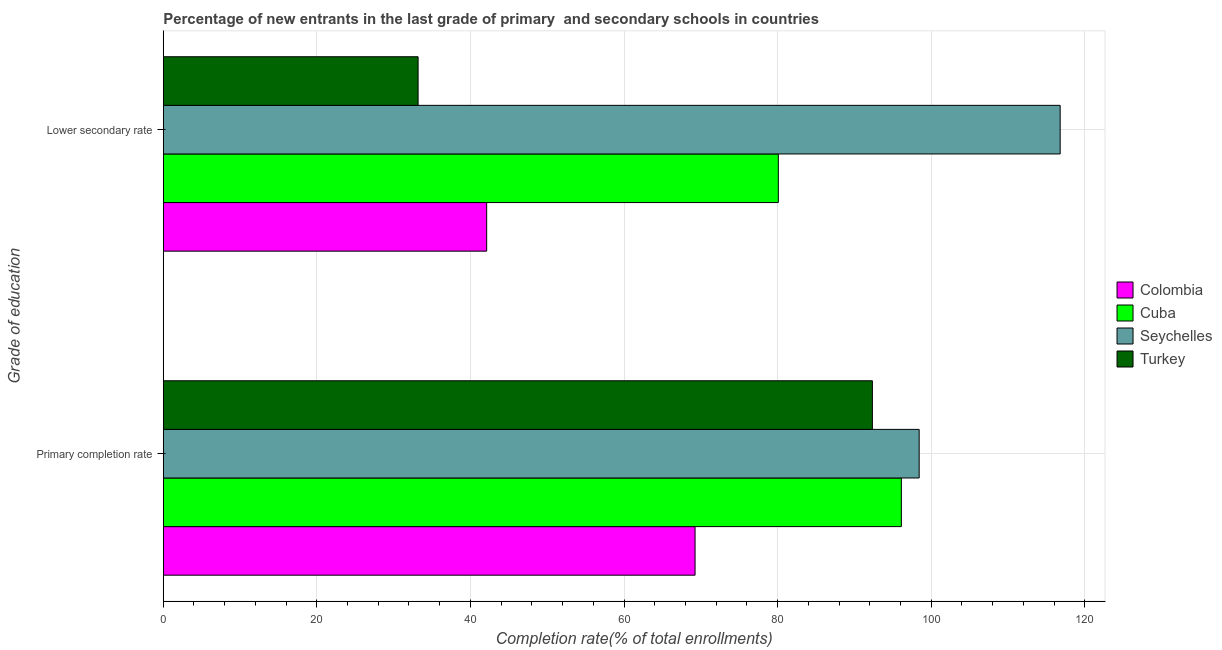How many different coloured bars are there?
Make the answer very short. 4. How many groups of bars are there?
Ensure brevity in your answer.  2. Are the number of bars on each tick of the Y-axis equal?
Ensure brevity in your answer.  Yes. How many bars are there on the 1st tick from the top?
Provide a short and direct response. 4. What is the label of the 2nd group of bars from the top?
Offer a terse response. Primary completion rate. What is the completion rate in primary schools in Cuba?
Offer a terse response. 96.12. Across all countries, what is the maximum completion rate in secondary schools?
Ensure brevity in your answer.  116.8. Across all countries, what is the minimum completion rate in secondary schools?
Make the answer very short. 33.19. In which country was the completion rate in secondary schools maximum?
Ensure brevity in your answer.  Seychelles. What is the total completion rate in secondary schools in the graph?
Your answer should be very brief. 272.2. What is the difference between the completion rate in secondary schools in Colombia and that in Cuba?
Make the answer very short. -37.98. What is the difference between the completion rate in primary schools in Colombia and the completion rate in secondary schools in Cuba?
Your answer should be very brief. -10.84. What is the average completion rate in secondary schools per country?
Keep it short and to the point. 68.05. What is the difference between the completion rate in secondary schools and completion rate in primary schools in Colombia?
Your answer should be compact. -27.14. In how many countries, is the completion rate in primary schools greater than 16 %?
Provide a short and direct response. 4. What is the ratio of the completion rate in secondary schools in Seychelles to that in Colombia?
Ensure brevity in your answer.  2.77. Is the completion rate in secondary schools in Cuba less than that in Turkey?
Ensure brevity in your answer.  No. What does the 2nd bar from the top in Primary completion rate represents?
Offer a very short reply. Seychelles. What does the 4th bar from the bottom in Primary completion rate represents?
Offer a terse response. Turkey. How many bars are there?
Keep it short and to the point. 8. How many countries are there in the graph?
Your answer should be compact. 4. How many legend labels are there?
Provide a short and direct response. 4. How are the legend labels stacked?
Offer a terse response. Vertical. What is the title of the graph?
Offer a very short reply. Percentage of new entrants in the last grade of primary  and secondary schools in countries. What is the label or title of the X-axis?
Make the answer very short. Completion rate(% of total enrollments). What is the label or title of the Y-axis?
Offer a terse response. Grade of education. What is the Completion rate(% of total enrollments) in Colombia in Primary completion rate?
Make the answer very short. 69.25. What is the Completion rate(% of total enrollments) of Cuba in Primary completion rate?
Offer a terse response. 96.12. What is the Completion rate(% of total enrollments) of Seychelles in Primary completion rate?
Offer a very short reply. 98.44. What is the Completion rate(% of total enrollments) of Turkey in Primary completion rate?
Provide a short and direct response. 92.35. What is the Completion rate(% of total enrollments) in Colombia in Lower secondary rate?
Offer a very short reply. 42.12. What is the Completion rate(% of total enrollments) in Cuba in Lower secondary rate?
Keep it short and to the point. 80.1. What is the Completion rate(% of total enrollments) in Seychelles in Lower secondary rate?
Provide a succinct answer. 116.8. What is the Completion rate(% of total enrollments) of Turkey in Lower secondary rate?
Offer a very short reply. 33.19. Across all Grade of education, what is the maximum Completion rate(% of total enrollments) in Colombia?
Your response must be concise. 69.25. Across all Grade of education, what is the maximum Completion rate(% of total enrollments) of Cuba?
Ensure brevity in your answer.  96.12. Across all Grade of education, what is the maximum Completion rate(% of total enrollments) in Seychelles?
Provide a succinct answer. 116.8. Across all Grade of education, what is the maximum Completion rate(% of total enrollments) of Turkey?
Provide a short and direct response. 92.35. Across all Grade of education, what is the minimum Completion rate(% of total enrollments) in Colombia?
Your response must be concise. 42.12. Across all Grade of education, what is the minimum Completion rate(% of total enrollments) of Cuba?
Offer a terse response. 80.1. Across all Grade of education, what is the minimum Completion rate(% of total enrollments) of Seychelles?
Your answer should be very brief. 98.44. Across all Grade of education, what is the minimum Completion rate(% of total enrollments) of Turkey?
Give a very brief answer. 33.19. What is the total Completion rate(% of total enrollments) of Colombia in the graph?
Ensure brevity in your answer.  111.37. What is the total Completion rate(% of total enrollments) of Cuba in the graph?
Offer a very short reply. 176.22. What is the total Completion rate(% of total enrollments) in Seychelles in the graph?
Your answer should be very brief. 215.24. What is the total Completion rate(% of total enrollments) of Turkey in the graph?
Ensure brevity in your answer.  125.53. What is the difference between the Completion rate(% of total enrollments) of Colombia in Primary completion rate and that in Lower secondary rate?
Your response must be concise. 27.14. What is the difference between the Completion rate(% of total enrollments) of Cuba in Primary completion rate and that in Lower secondary rate?
Give a very brief answer. 16.02. What is the difference between the Completion rate(% of total enrollments) of Seychelles in Primary completion rate and that in Lower secondary rate?
Make the answer very short. -18.36. What is the difference between the Completion rate(% of total enrollments) in Turkey in Primary completion rate and that in Lower secondary rate?
Give a very brief answer. 59.16. What is the difference between the Completion rate(% of total enrollments) of Colombia in Primary completion rate and the Completion rate(% of total enrollments) of Cuba in Lower secondary rate?
Your answer should be compact. -10.84. What is the difference between the Completion rate(% of total enrollments) of Colombia in Primary completion rate and the Completion rate(% of total enrollments) of Seychelles in Lower secondary rate?
Offer a very short reply. -47.55. What is the difference between the Completion rate(% of total enrollments) in Colombia in Primary completion rate and the Completion rate(% of total enrollments) in Turkey in Lower secondary rate?
Keep it short and to the point. 36.07. What is the difference between the Completion rate(% of total enrollments) of Cuba in Primary completion rate and the Completion rate(% of total enrollments) of Seychelles in Lower secondary rate?
Your answer should be very brief. -20.68. What is the difference between the Completion rate(% of total enrollments) of Cuba in Primary completion rate and the Completion rate(% of total enrollments) of Turkey in Lower secondary rate?
Your answer should be very brief. 62.94. What is the difference between the Completion rate(% of total enrollments) of Seychelles in Primary completion rate and the Completion rate(% of total enrollments) of Turkey in Lower secondary rate?
Provide a short and direct response. 65.26. What is the average Completion rate(% of total enrollments) in Colombia per Grade of education?
Your response must be concise. 55.69. What is the average Completion rate(% of total enrollments) of Cuba per Grade of education?
Keep it short and to the point. 88.11. What is the average Completion rate(% of total enrollments) of Seychelles per Grade of education?
Your answer should be very brief. 107.62. What is the average Completion rate(% of total enrollments) in Turkey per Grade of education?
Your answer should be very brief. 62.77. What is the difference between the Completion rate(% of total enrollments) of Colombia and Completion rate(% of total enrollments) of Cuba in Primary completion rate?
Make the answer very short. -26.87. What is the difference between the Completion rate(% of total enrollments) in Colombia and Completion rate(% of total enrollments) in Seychelles in Primary completion rate?
Provide a succinct answer. -29.19. What is the difference between the Completion rate(% of total enrollments) of Colombia and Completion rate(% of total enrollments) of Turkey in Primary completion rate?
Offer a terse response. -23.09. What is the difference between the Completion rate(% of total enrollments) in Cuba and Completion rate(% of total enrollments) in Seychelles in Primary completion rate?
Your answer should be compact. -2.32. What is the difference between the Completion rate(% of total enrollments) of Cuba and Completion rate(% of total enrollments) of Turkey in Primary completion rate?
Provide a succinct answer. 3.77. What is the difference between the Completion rate(% of total enrollments) of Seychelles and Completion rate(% of total enrollments) of Turkey in Primary completion rate?
Give a very brief answer. 6.09. What is the difference between the Completion rate(% of total enrollments) in Colombia and Completion rate(% of total enrollments) in Cuba in Lower secondary rate?
Offer a terse response. -37.98. What is the difference between the Completion rate(% of total enrollments) of Colombia and Completion rate(% of total enrollments) of Seychelles in Lower secondary rate?
Give a very brief answer. -74.69. What is the difference between the Completion rate(% of total enrollments) of Colombia and Completion rate(% of total enrollments) of Turkey in Lower secondary rate?
Provide a succinct answer. 8.93. What is the difference between the Completion rate(% of total enrollments) in Cuba and Completion rate(% of total enrollments) in Seychelles in Lower secondary rate?
Keep it short and to the point. -36.71. What is the difference between the Completion rate(% of total enrollments) in Cuba and Completion rate(% of total enrollments) in Turkey in Lower secondary rate?
Offer a very short reply. 46.91. What is the difference between the Completion rate(% of total enrollments) in Seychelles and Completion rate(% of total enrollments) in Turkey in Lower secondary rate?
Make the answer very short. 83.62. What is the ratio of the Completion rate(% of total enrollments) of Colombia in Primary completion rate to that in Lower secondary rate?
Give a very brief answer. 1.64. What is the ratio of the Completion rate(% of total enrollments) of Cuba in Primary completion rate to that in Lower secondary rate?
Provide a short and direct response. 1.2. What is the ratio of the Completion rate(% of total enrollments) in Seychelles in Primary completion rate to that in Lower secondary rate?
Provide a short and direct response. 0.84. What is the ratio of the Completion rate(% of total enrollments) of Turkey in Primary completion rate to that in Lower secondary rate?
Your answer should be very brief. 2.78. What is the difference between the highest and the second highest Completion rate(% of total enrollments) of Colombia?
Keep it short and to the point. 27.14. What is the difference between the highest and the second highest Completion rate(% of total enrollments) of Cuba?
Make the answer very short. 16.02. What is the difference between the highest and the second highest Completion rate(% of total enrollments) in Seychelles?
Provide a short and direct response. 18.36. What is the difference between the highest and the second highest Completion rate(% of total enrollments) of Turkey?
Provide a succinct answer. 59.16. What is the difference between the highest and the lowest Completion rate(% of total enrollments) of Colombia?
Ensure brevity in your answer.  27.14. What is the difference between the highest and the lowest Completion rate(% of total enrollments) of Cuba?
Provide a succinct answer. 16.02. What is the difference between the highest and the lowest Completion rate(% of total enrollments) in Seychelles?
Your answer should be compact. 18.36. What is the difference between the highest and the lowest Completion rate(% of total enrollments) of Turkey?
Provide a succinct answer. 59.16. 